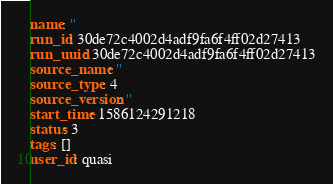<code> <loc_0><loc_0><loc_500><loc_500><_YAML_>name: ''
run_id: 30de72c4002d4adf9fa6f4ff02d27413
run_uuid: 30de72c4002d4adf9fa6f4ff02d27413
source_name: ''
source_type: 4
source_version: ''
start_time: 1586124291218
status: 3
tags: []
user_id: quasi
</code> 